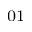<formula> <loc_0><loc_0><loc_500><loc_500>_ { 0 1 }</formula> 